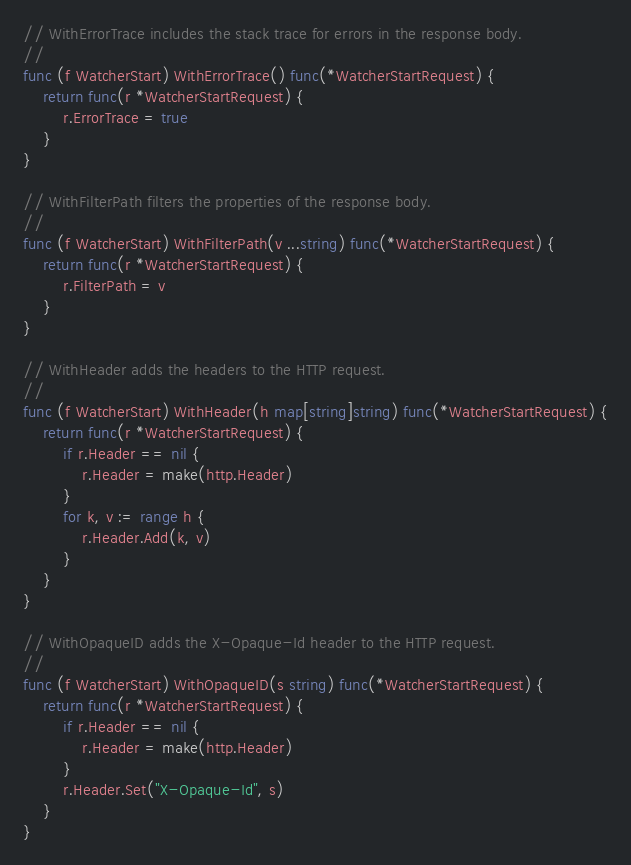Convert code to text. <code><loc_0><loc_0><loc_500><loc_500><_Go_>// WithErrorTrace includes the stack trace for errors in the response body.
//
func (f WatcherStart) WithErrorTrace() func(*WatcherStartRequest) {
	return func(r *WatcherStartRequest) {
		r.ErrorTrace = true
	}
}

// WithFilterPath filters the properties of the response body.
//
func (f WatcherStart) WithFilterPath(v ...string) func(*WatcherStartRequest) {
	return func(r *WatcherStartRequest) {
		r.FilterPath = v
	}
}

// WithHeader adds the headers to the HTTP request.
//
func (f WatcherStart) WithHeader(h map[string]string) func(*WatcherStartRequest) {
	return func(r *WatcherStartRequest) {
		if r.Header == nil {
			r.Header = make(http.Header)
		}
		for k, v := range h {
			r.Header.Add(k, v)
		}
	}
}

// WithOpaqueID adds the X-Opaque-Id header to the HTTP request.
//
func (f WatcherStart) WithOpaqueID(s string) func(*WatcherStartRequest) {
	return func(r *WatcherStartRequest) {
		if r.Header == nil {
			r.Header = make(http.Header)
		}
		r.Header.Set("X-Opaque-Id", s)
	}
}
</code> 